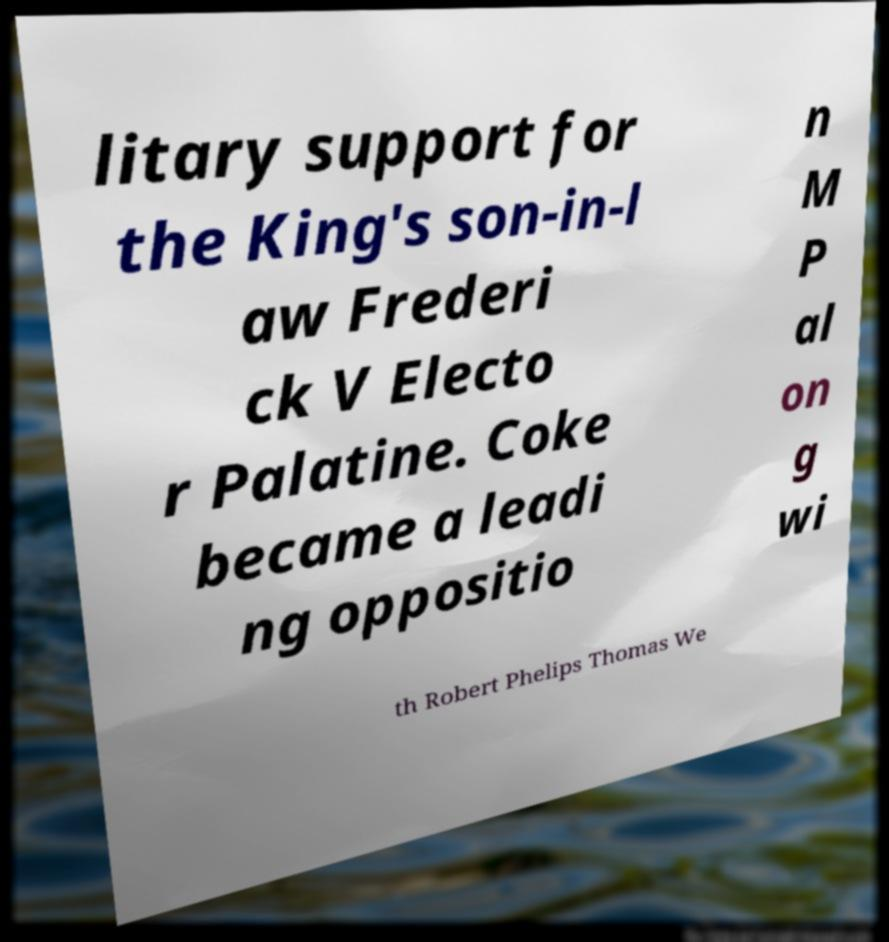I need the written content from this picture converted into text. Can you do that? litary support for the King's son-in-l aw Frederi ck V Electo r Palatine. Coke became a leadi ng oppositio n M P al on g wi th Robert Phelips Thomas We 